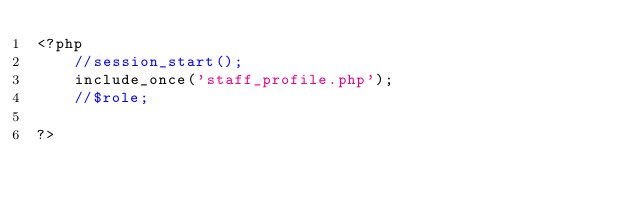<code> <loc_0><loc_0><loc_500><loc_500><_PHP_><?php
	//session_start();
	include_once('staff_profile.php');
	//$role;
	
?></code> 